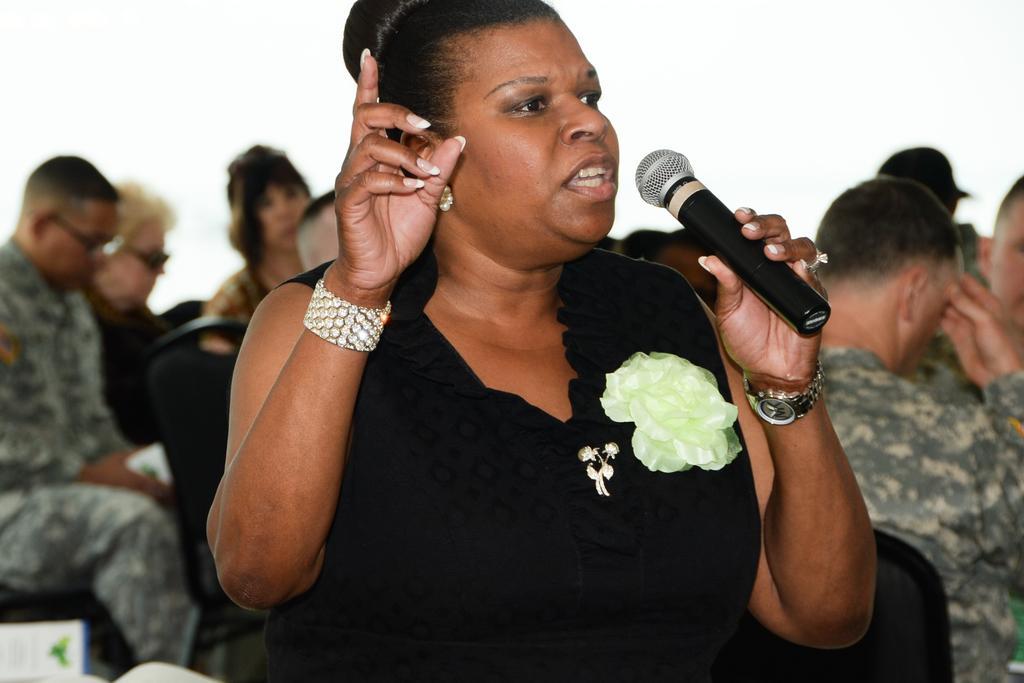Please provide a concise description of this image. In this picture a lady is standing. And she is holding a mike on her left hand and she is talking. To her left hand there is watch, to her middle finger there is stone ring. And to her right hand there is a stone bangle. To her Right hand there is man sitting with the uniform, Behind her there are two ladies siting. And to her left hand there is man sitting on the black chair. 